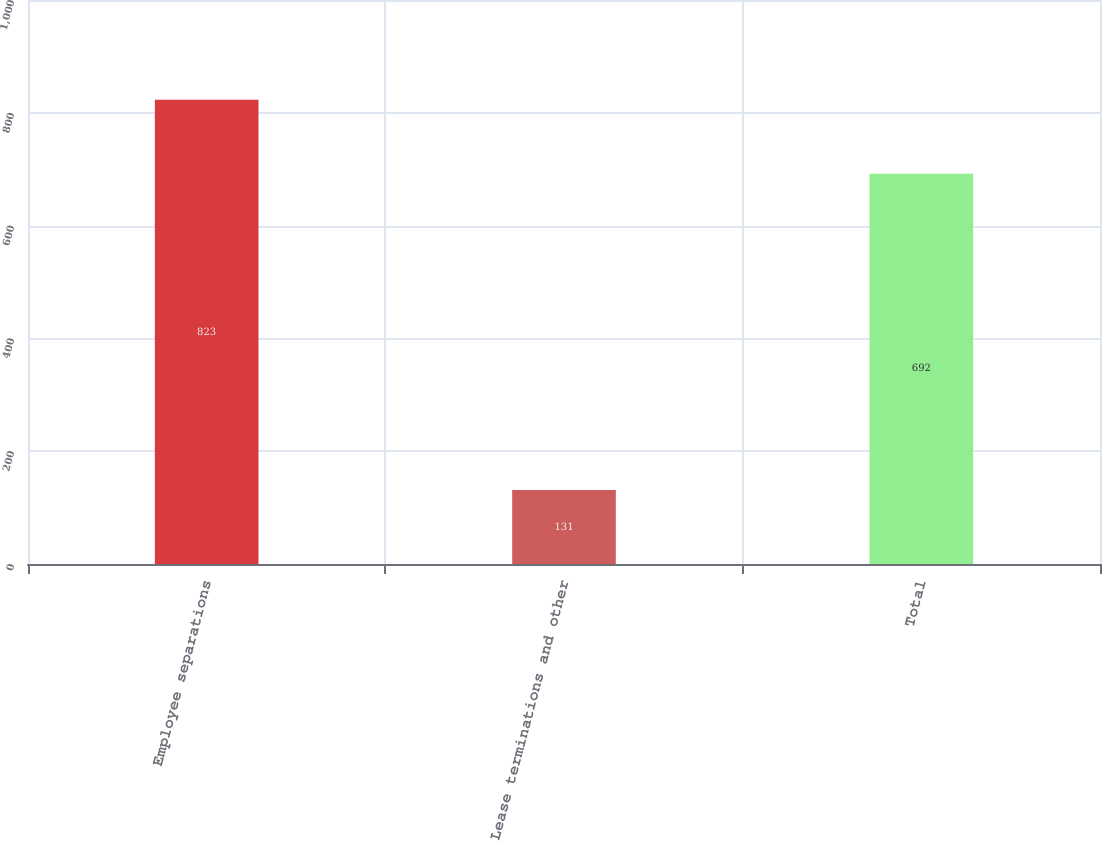<chart> <loc_0><loc_0><loc_500><loc_500><bar_chart><fcel>Employee separations<fcel>Lease terminations and other<fcel>Total<nl><fcel>823<fcel>131<fcel>692<nl></chart> 